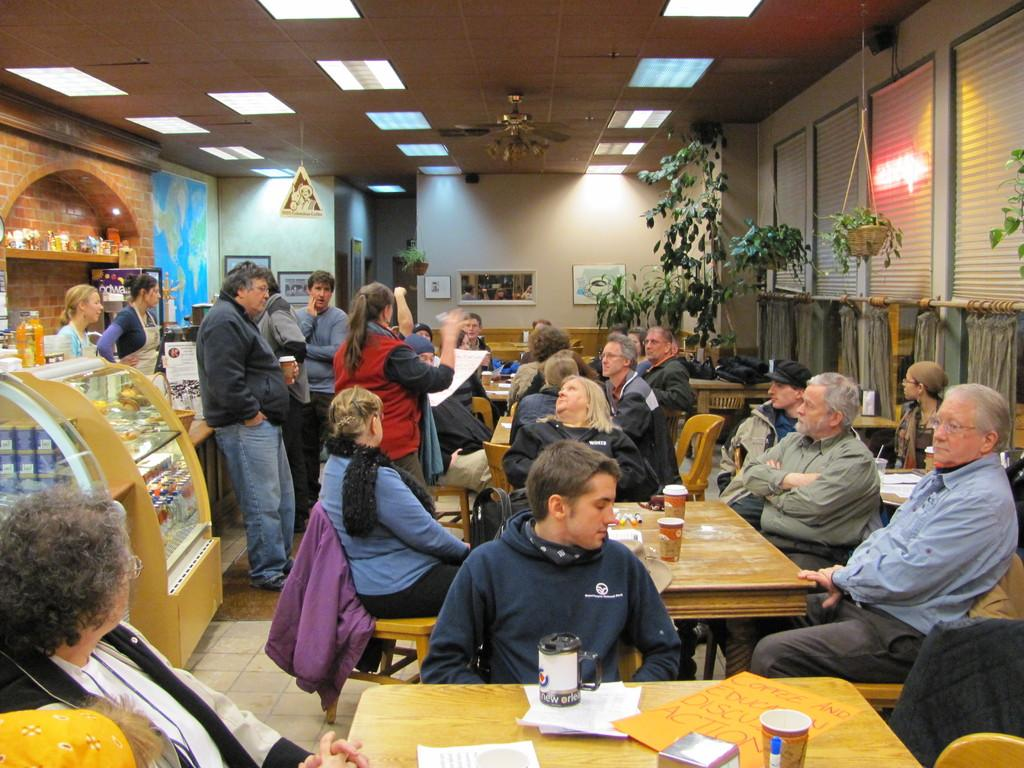What are the people in the image doing? There is a group of people sitting together in the image. What are the people sitting on? The people are sitting on chairs. How are the chairs arranged in the image? The chairs are arranged around dining tables. What can be seen on the right side of the image? There is a tree on the right side of the image. What is visible at the top of the image? There is a light visible at the top of the image. What type of note is being passed around the table in the image? There is no note being passed around the table in the image; it only shows people sitting together. What action is the fruit taking in the image? There is no fruit present in the image, so no action can be attributed to it. 